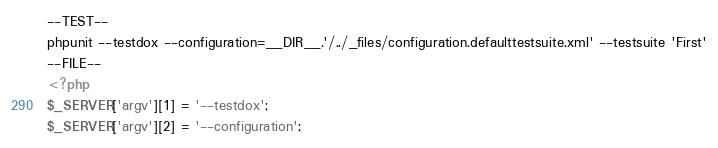Convert code to text. <code><loc_0><loc_0><loc_500><loc_500><_PHP_>--TEST--
phpunit --testdox --configuration=__DIR__.'/../_files/configuration.defaulttestsuite.xml' --testsuite 'First'
--FILE--
<?php
$_SERVER['argv'][1] = '--testdox';
$_SERVER['argv'][2] = '--configuration';</code> 